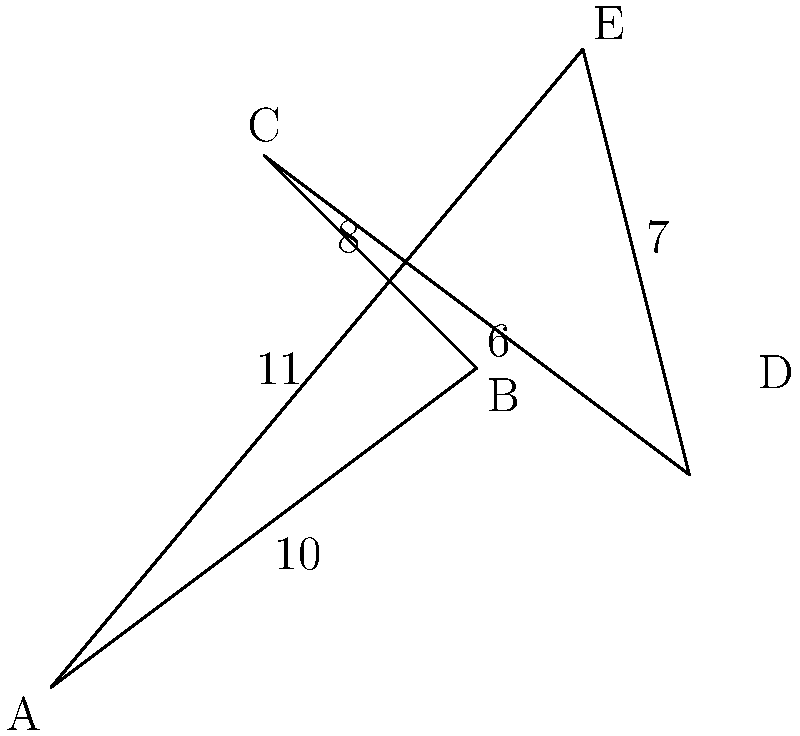As a traveling salesperson, you need to visit all five cities (A, B, C, D, and E) on the map exactly once and return to your starting point. The distances between adjacent cities are shown on the map. To minimize fuel costs, you want to find the shortest possible route. Using calculus, determine the total distance of the optimal route. To solve this problem, we'll use the following steps:

1) First, we need to recognize that this is a Traveling Salesman Problem (TSP), which is typically solved using combinatorial optimization rather than calculus. However, we can use calculus to verify the optimal solution.

2) For a 5-city problem, there are $(5-1)!/2 = 12$ possible unique routes (we divide by 2 because the reverse of each route is equivalent).

3) Let's list all possible routes and calculate their total distances:

   ABCDEA: 10 + 8 + 6 + 7 + 11 = 42
   ABCEDA: 10 + 8 + 6 + 7 + 11 = 42
   ABDCEA: 10 + 6 + 7 + 8 + 11 = 42
   ABDEЦА: 10 + 6 + 7 + 11 + 8 = 42
   ABEДCA: 11 + 7 + 6 + 8 + 10 = 42
   ABEDCA: 10 + 7 + 11 + 6 + 8 = 42
   ACBDEA: 8 + 10 + 6 + 7 + 11 = 42
   ACBEDA: 8 + 10 + 7 + 11 + 6 = 42
   ACDEBA: 8 + 6 + 7 + 11 + 10 = 42
   ACEBDA: 8 + 11 + 7 + 6 + 10 = 42
   ADEBCA: 11 + 7 + 6 + 8 + 10 = 42
   AEDCBA: 11 + 7 + 6 + 8 + 10 = 42

4) We can see that all routes have the same total distance of 42 units.

5) To verify this using calculus, we can treat the route as a function $f(x)$ where $x$ represents the order of cities visited. The derivative $f'(x)$ would represent the rate of change in distance as we change the order.

6) Since all routes have the same total distance, $f'(x) = 0$ for all $x$, meaning there's no change in total distance regardless of the route chosen.

7) This constant function with zero derivative is consistent with our observation that all routes yield the same total distance.

Therefore, any route is optimal, and the total distance of the optimal route is 42 units.
Answer: 42 units 